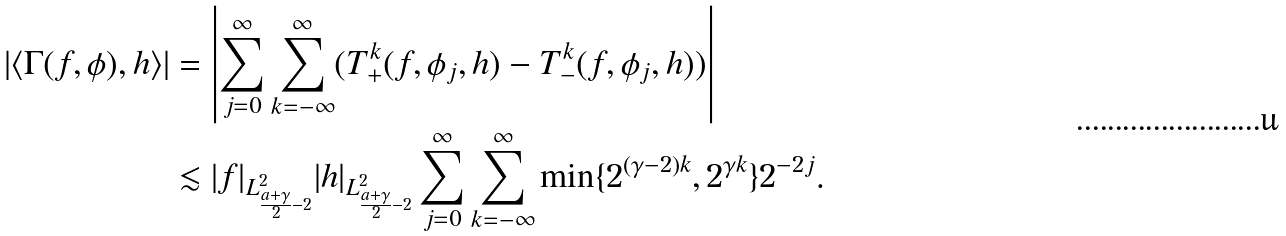<formula> <loc_0><loc_0><loc_500><loc_500>| \langle \Gamma ( f , \phi ) , h \rangle | & = \left | \sum _ { j = 0 } ^ { \infty } \sum _ { k = - \infty } ^ { \infty } ( T ^ { k } _ { + } ( f , \phi _ { j } , h ) - T ^ { k } _ { - } ( f , \phi _ { j } , h ) ) \right | \\ & \lesssim | f | _ { L ^ { 2 } _ { \frac { a + \gamma } { 2 } - 2 } } | h | _ { L ^ { 2 } _ { \frac { a + \gamma } { 2 } - 2 } } \sum _ { j = 0 } ^ { \infty } \sum _ { k = - \infty } ^ { \infty } \min \{ 2 ^ { ( \gamma - 2 ) k } , 2 ^ { \gamma k } \} 2 ^ { - 2 j } .</formula> 